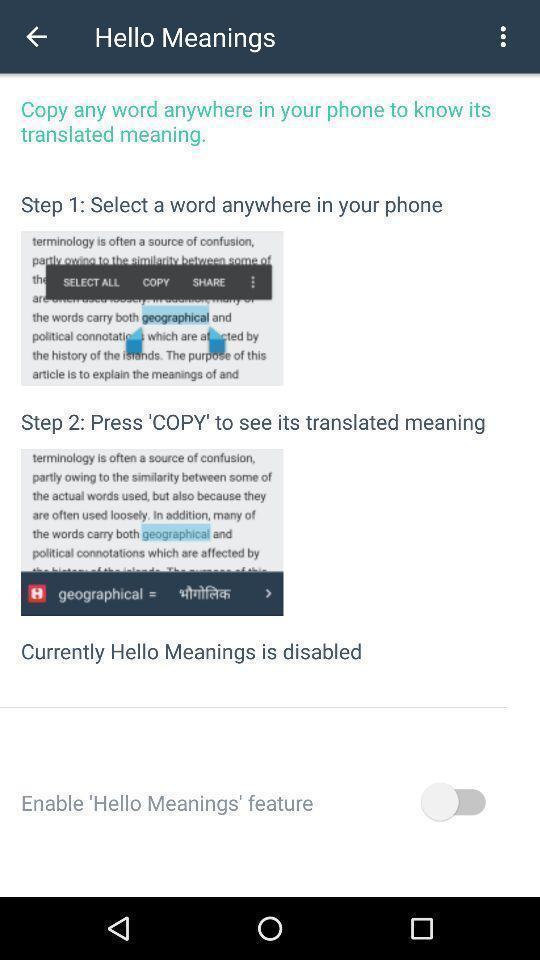Summarize the main components in this picture. Screen showing steps. 